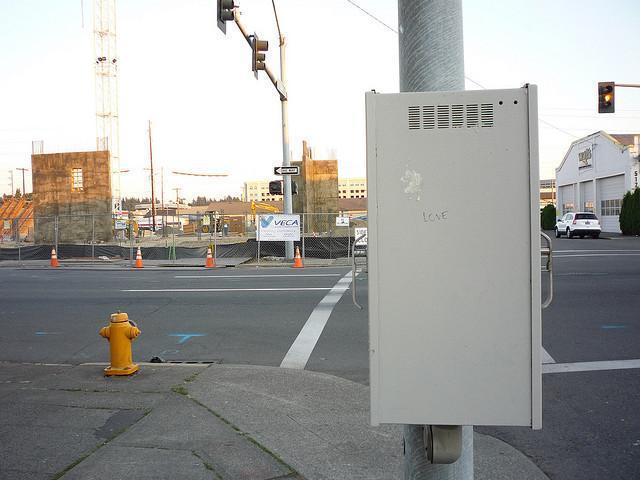How many cones can easily be seen?
Give a very brief answer. 4. 